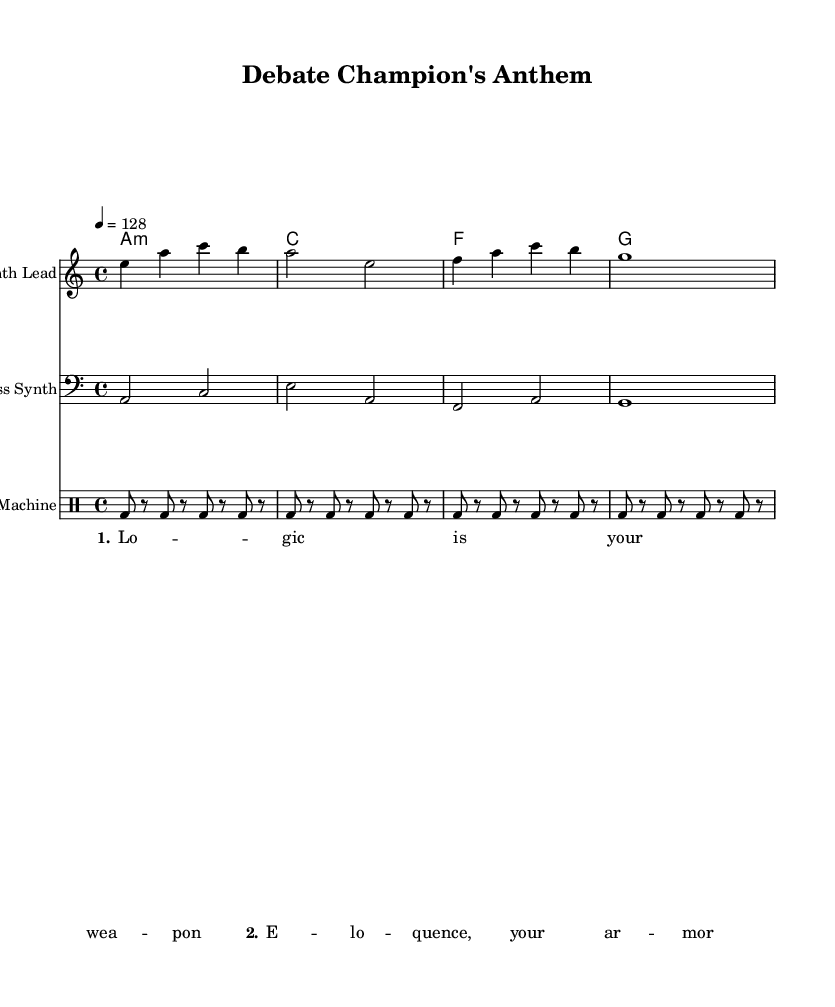What is the key signature of this music? The key signature is indicated at the beginning of the score and shows an 'A' as the root note of the minor scale. This indicates the key signature is A minor, which has no sharps or flats.
Answer: A minor What is the time signature of this music? The time signature is found at the beginning of the score and shows '4/4', indicating four beats in a measure and a quarter note receives one beat.
Answer: 4/4 What is the tempo marking of this music? The tempo marking is also shown at the beginning of the score with the indication '4 = 128', which means there are 128 beats per minute with a quarter note serving as the pulse.
Answer: 128 What types of instruments are used in this composition? By examining the score, we identify three staves: one for the Synth Lead, one for the Bass Synth, and one for the Drum Machine. This indicates the instruments involved: a synthesizer for the lead, another synthesizer for the bass part, and a drum machine for rhythm.
Answer: Synthesizer, Bass Synth, Drum Machine What is the lyrical theme of the spoken word samples? The spoken word samples feature motivational phrases as indicated in the lyrics—“Logic is your weapon” and “Eloquence, your armor.” This captures a theme of empowerment and readiness, suitable for pre-debate preparation.
Answer: Empowerment and readiness Which note is played in the first measure of the Synth Lead? The first measure of the Synth Lead consists of the notes E, A, C, and B, played in sequence. Thus, the initial note is the first in that sequence.
Answer: E What is the function of the drum machine in this piece? The drum machine plays a consistent pattern of bass drum hits throughout the score, setting up a rhythmic foundation that is typical for electronic music which helps maintain the upbeat feel essential for warm-ups.
Answer: Rhythmic foundation 